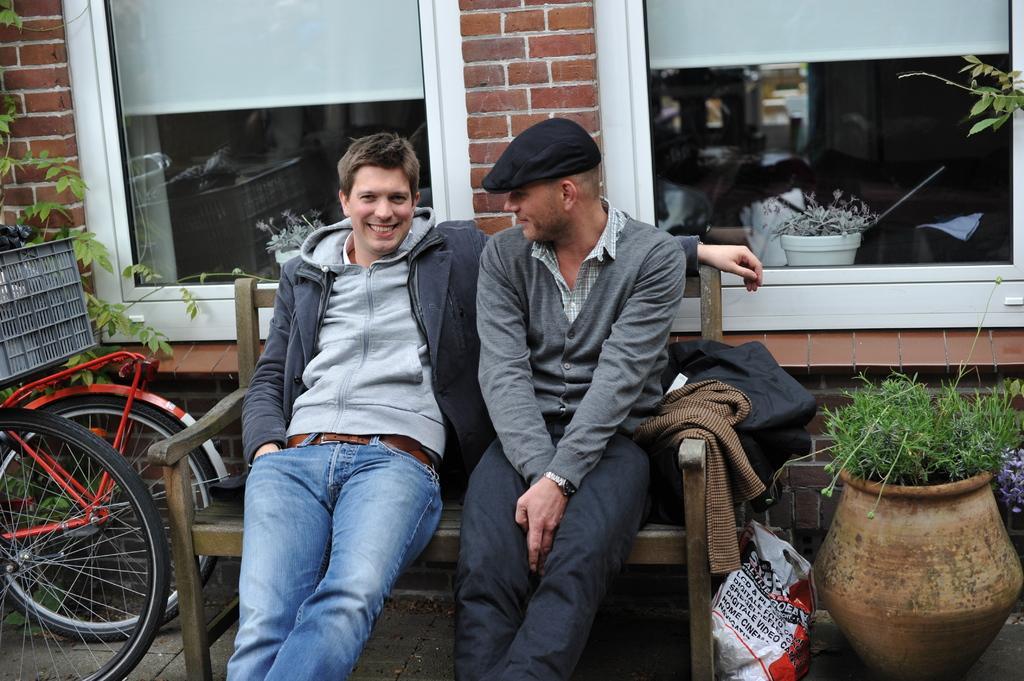Please provide a concise description of this image. In this picture we can see people sitting on a bench, here we can see bicycles, plants in the pots and in the background we can see a wall, people and some objects. 